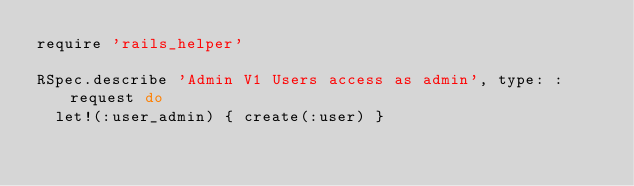<code> <loc_0><loc_0><loc_500><loc_500><_Ruby_>require 'rails_helper'

RSpec.describe 'Admin V1 Users access as admin', type: :request do
  let!(:user_admin) { create(:user) }
</code> 